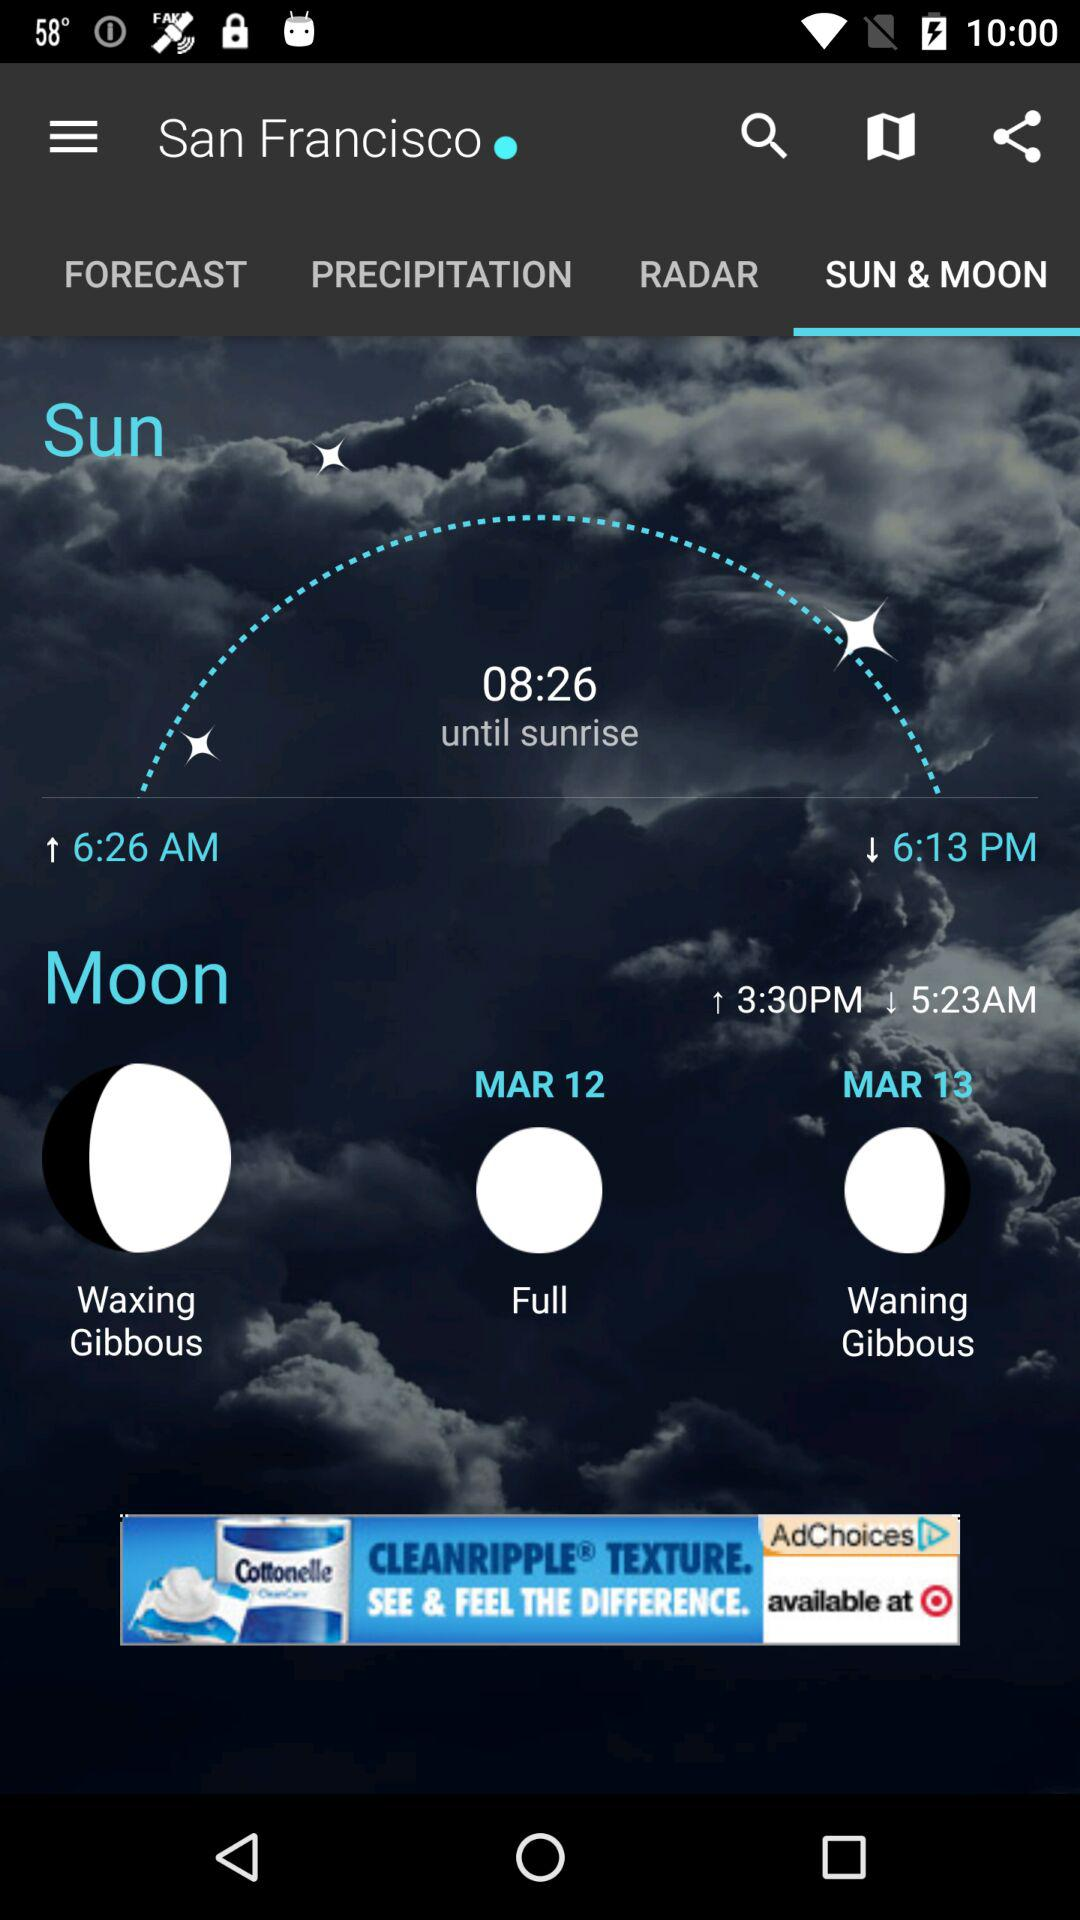What is the location? The location is San Francisco. 